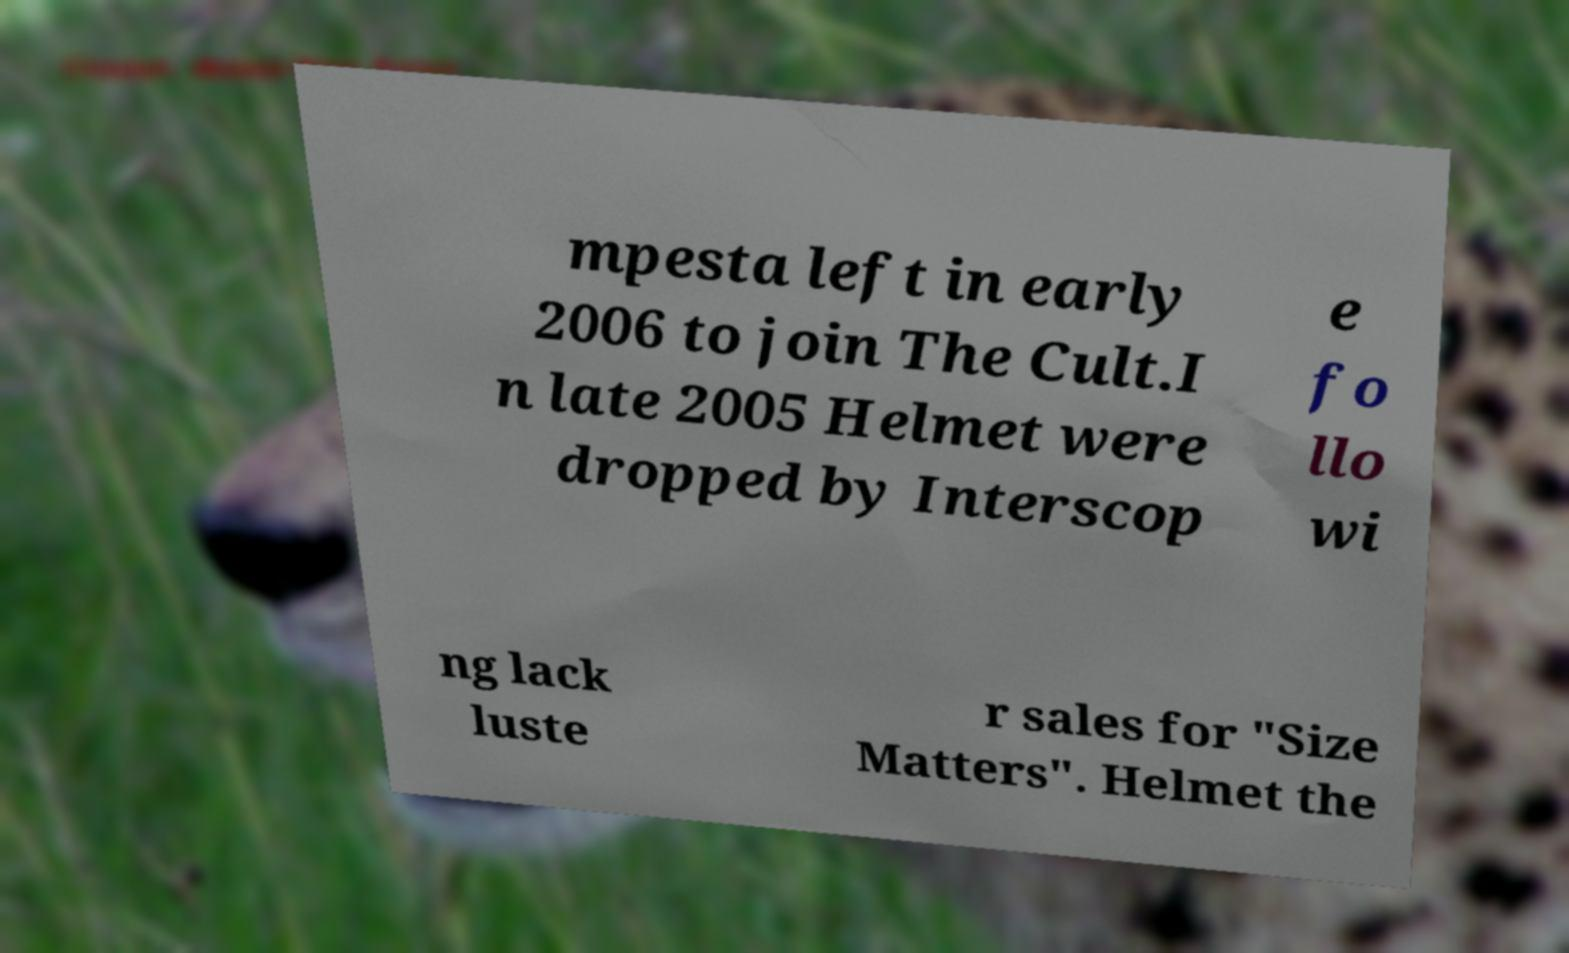Can you accurately transcribe the text from the provided image for me? mpesta left in early 2006 to join The Cult.I n late 2005 Helmet were dropped by Interscop e fo llo wi ng lack luste r sales for "Size Matters". Helmet the 